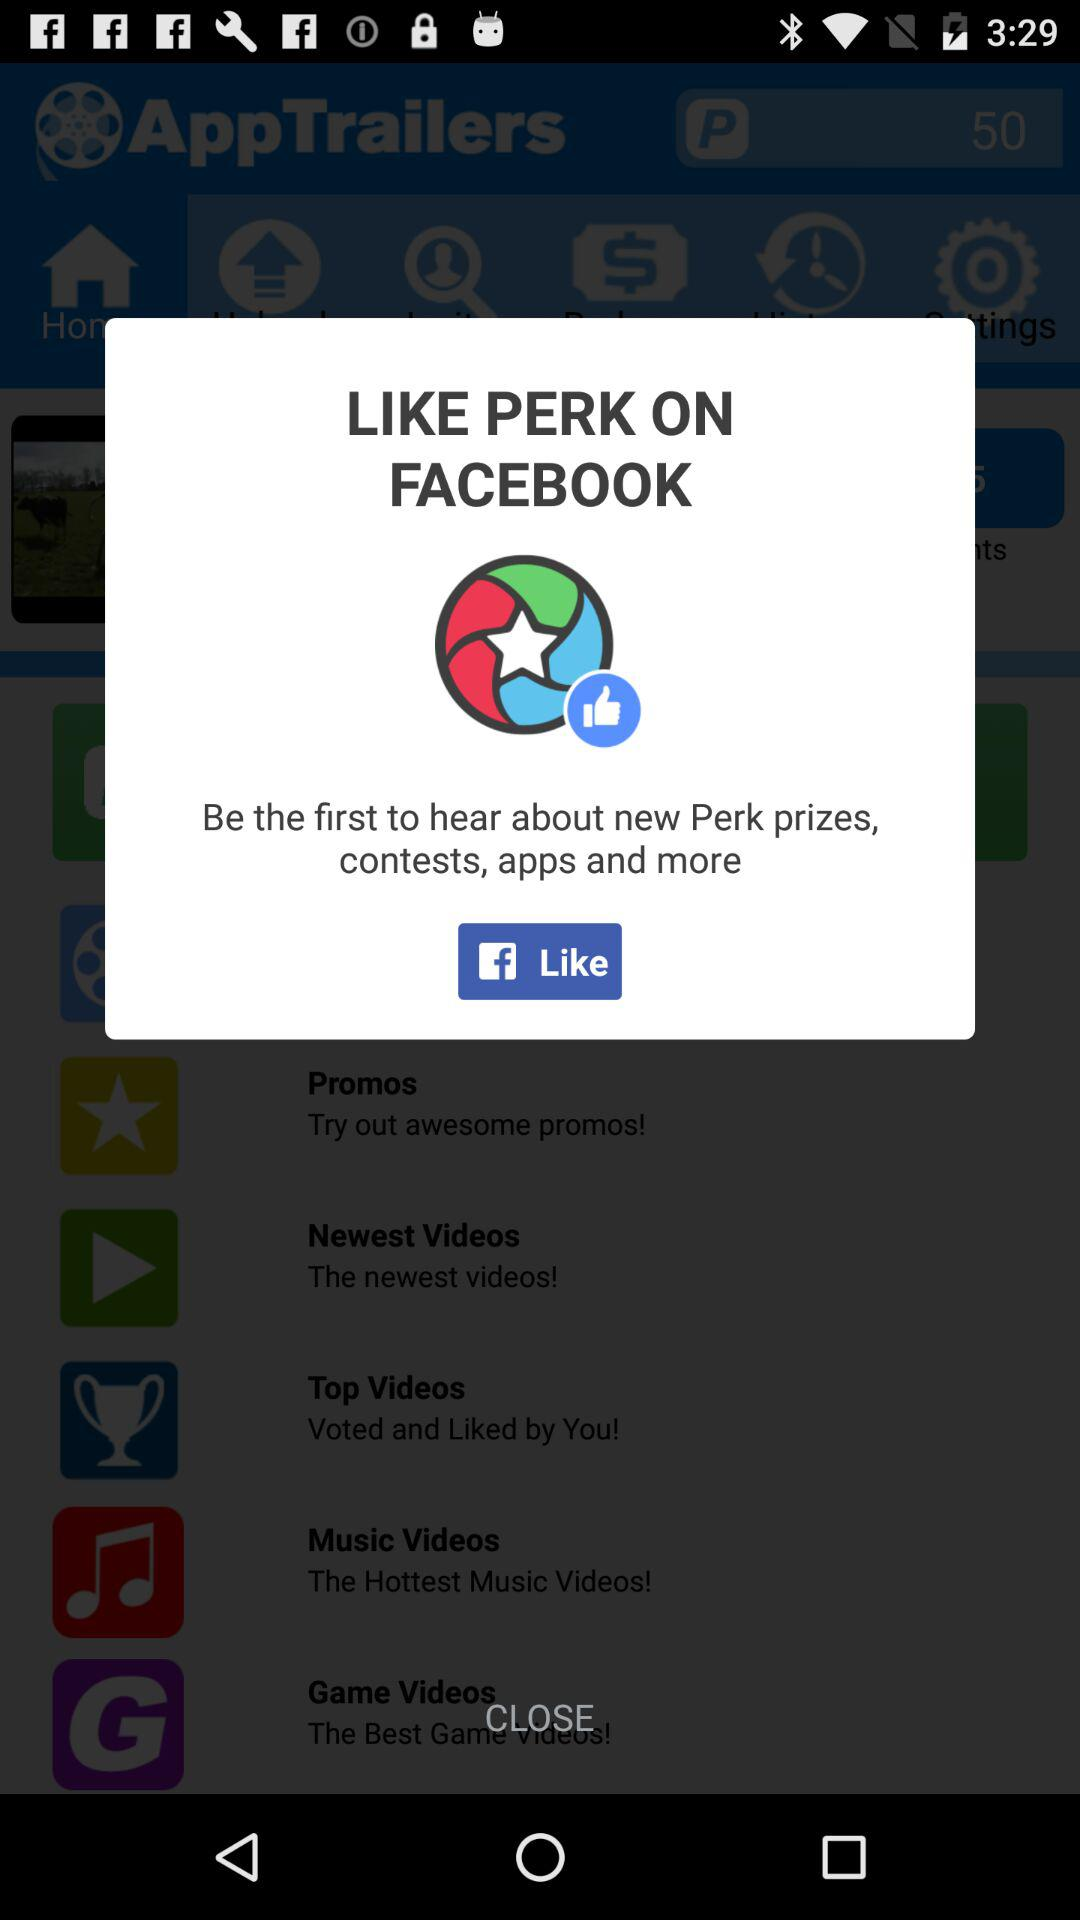Through what account Perk page can be liked? The account is "FACEBOOK". 